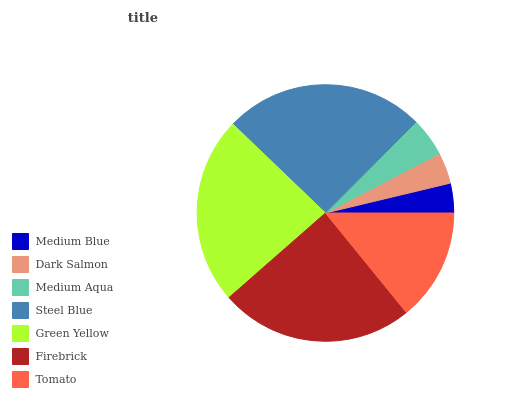Is Medium Blue the minimum?
Answer yes or no. Yes. Is Steel Blue the maximum?
Answer yes or no. Yes. Is Dark Salmon the minimum?
Answer yes or no. No. Is Dark Salmon the maximum?
Answer yes or no. No. Is Dark Salmon greater than Medium Blue?
Answer yes or no. Yes. Is Medium Blue less than Dark Salmon?
Answer yes or no. Yes. Is Medium Blue greater than Dark Salmon?
Answer yes or no. No. Is Dark Salmon less than Medium Blue?
Answer yes or no. No. Is Tomato the high median?
Answer yes or no. Yes. Is Tomato the low median?
Answer yes or no. Yes. Is Firebrick the high median?
Answer yes or no. No. Is Green Yellow the low median?
Answer yes or no. No. 